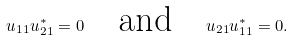<formula> <loc_0><loc_0><loc_500><loc_500>u _ { 1 1 } u _ { 2 1 } ^ { * } = 0 \quad \text {and} \quad u _ { 2 1 } u _ { 1 1 } ^ { * } = 0 .</formula> 